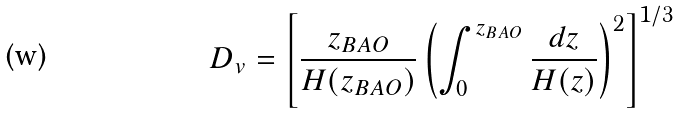<formula> <loc_0><loc_0><loc_500><loc_500>D _ { v } = \left [ \frac { z _ { B A O } } { H ( z _ { B A O } ) } \left ( \int _ { 0 } ^ { z _ { B A O } } \frac { d z } { H ( z ) } \right ) ^ { 2 } \right ] ^ { 1 / 3 }</formula> 